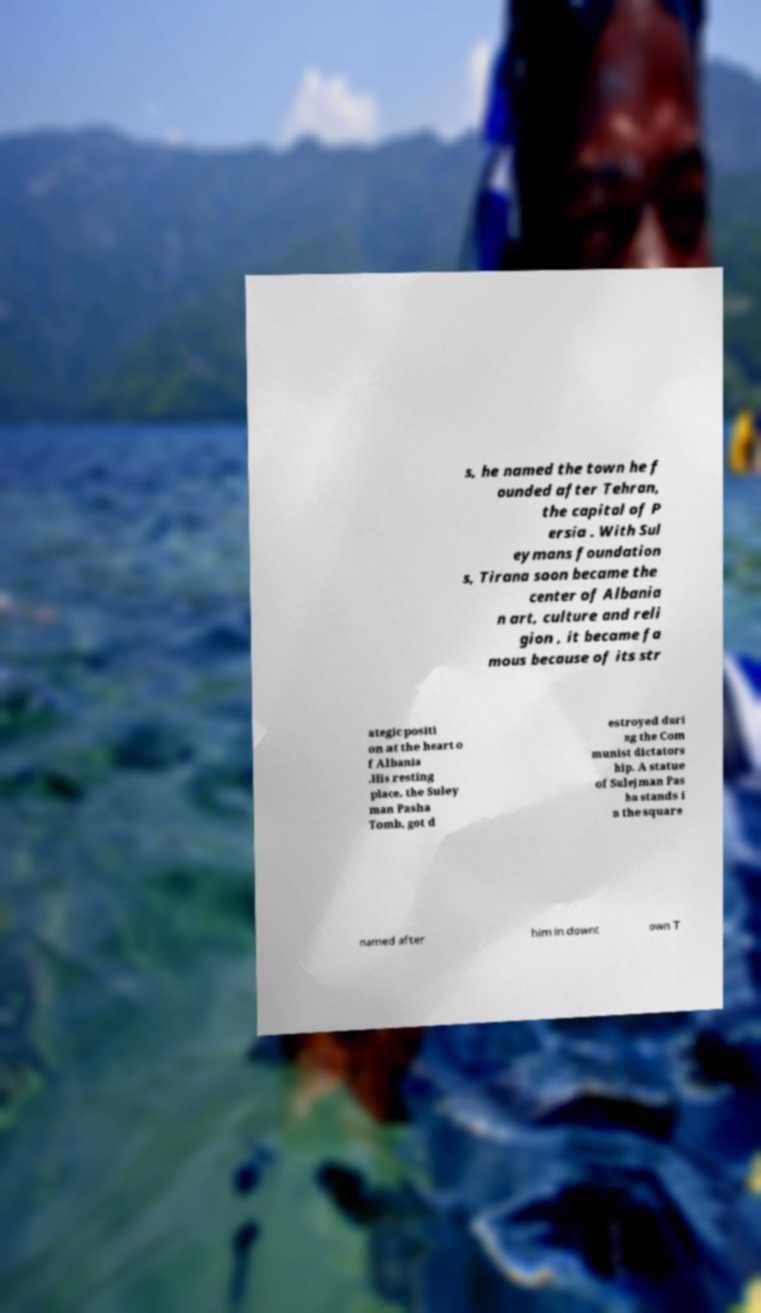Can you accurately transcribe the text from the provided image for me? s, he named the town he f ounded after Tehran, the capital of P ersia . With Sul eymans foundation s, Tirana soon became the center of Albania n art, culture and reli gion , it became fa mous because of its str ategic positi on at the heart o f Albania .His resting place, the Suley man Pasha Tomb, got d estroyed duri ng the Com munist dictators hip. A statue of Sulejman Pas ha stands i n the square named after him in downt own T 